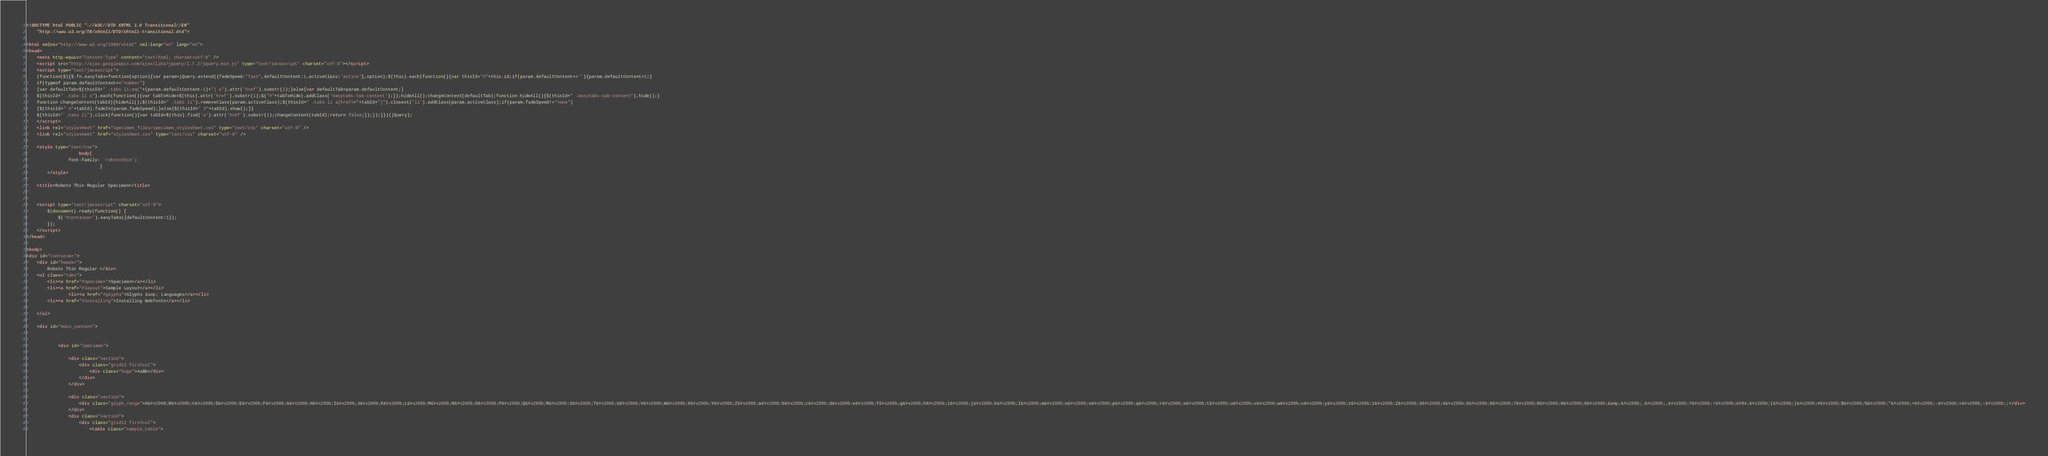Convert code to text. <code><loc_0><loc_0><loc_500><loc_500><_HTML_><!DOCTYPE html PUBLIC "-//W3C//DTD XHTML 1.0 Transitional//EN"
	"http://www.w3.org/TR/xhtml1/DTD/xhtml1-transitional.dtd">

<html xmlns="http://www.w3.org/1999/xhtml" xml:lang="en" lang="en">
<head>
	<meta http-equiv="Content-Type" content="text/html; charset=utf-8" />
	<script src="http://ajax.googleapis.com/ajax/libs/jquery/1.7.2/jquery.min.js" type="text/javascript" charset="utf-8"></script>
	<script type="text/javascript">
	(function($){$.fn.easyTabs=function(option){var param=jQuery.extend({fadeSpeed:"fast",defaultContent:1,activeClass:'active'},option);$(this).each(function(){var thisId="#"+this.id;if(param.defaultContent==''){param.defaultContent=1;}
	if(typeof param.defaultContent=="number")
	{var defaultTab=$(thisId+" .tabs li:eq("+(param.defaultContent-1)+") a").attr('href').substr(1);}else{var defaultTab=param.defaultContent;}
	$(thisId+" .tabs li a").each(function(){var tabToHide=$(this).attr('href').substr(1);$("#"+tabToHide).addClass('easytabs-tab-content');});hideAll();changeContent(defaultTab);function hideAll(){$(thisId+" .easytabs-tab-content").hide();}
	function changeContent(tabId){hideAll();$(thisId+" .tabs li").removeClass(param.activeClass);$(thisId+" .tabs li a[href=#"+tabId+"]").closest('li').addClass(param.activeClass);if(param.fadeSpeed!="none")
	{$(thisId+" #"+tabId).fadeIn(param.fadeSpeed);}else{$(thisId+" #"+tabId).show();}}
	$(thisId+" .tabs li").click(function(){var tabId=$(this).find('a').attr('href').substr(1);changeContent(tabId);return false;});});}})(jQuery);
	</script>
	<link rel="stylesheet" href="specimen_files/specimen_stylesheet.css" type="text/css" charset="utf-8" />
	<link rel="stylesheet" href="stylesheet.css" type="text/css" charset="utf-8" />

	<style type="text/css">
					body{
				font-family: 'robotothin';
							}
		</style>

	<title>Roboto Thin Regular Specimen</title>
	
	
	<script type="text/javascript" charset="utf-8">
		$(document).ready(function() {
			$('#container').easyTabs({defaultContent:1});
		});
	</script>
</head>

<body>
<div id="container">
	<div id="header">
		Roboto Thin Regular	</div>
	<ul class="tabs">
		<li><a href="#specimen">Specimen</a></li>
		<li><a href="#layout">Sample Layout</a></li>
				<li><a href="#glyphs">Glyphs &amp; Languages</a></li>
		<li><a href="#installing">Installing Webfonts</a></li>
		
	</ul>
	
	<div id="main_content">

		
			<div id="specimen">
		
				<div class="section">
					<div class="grid12 firstcol">
						<div class="huge">AaBb</div>
					</div>
				</div>
		
				<div class="section">
					<div class="glyph_range">A&#x200B;B&#x200b;C&#x200b;D&#x200b;E&#x200b;F&#x200b;G&#x200b;H&#x200b;I&#x200b;J&#x200b;K&#x200b;L&#x200b;M&#x200b;N&#x200b;O&#x200b;P&#x200b;Q&#x200b;R&#x200b;S&#x200b;T&#x200b;U&#x200b;V&#x200b;W&#x200b;X&#x200b;Y&#x200b;Z&#x200b;a&#x200b;b&#x200b;c&#x200b;d&#x200b;e&#x200b;f&#x200b;g&#x200b;h&#x200b;i&#x200b;j&#x200b;k&#x200b;l&#x200b;m&#x200b;n&#x200b;o&#x200b;p&#x200b;q&#x200b;r&#x200b;s&#x200b;t&#x200b;u&#x200b;v&#x200b;w&#x200b;x&#x200b;y&#x200b;z&#x200b;1&#x200b;2&#x200b;3&#x200b;4&#x200b;5&#x200b;6&#x200b;7&#x200b;8&#x200b;9&#x200b;0&#x200b;&amp;&#x200b;.&#x200b;,&#x200b;?&#x200b;!&#x200b;&#64;&#x200b;(&#x200b;)&#x200b;#&#x200b;$&#x200b;%&#x200b;*&#x200b;+&#x200b;-&#x200b;=&#x200b;:&#x200b;;</div>
				</div>
				<div class="section">
					<div class="grid12 firstcol">
						<table class="sample_table"></code> 